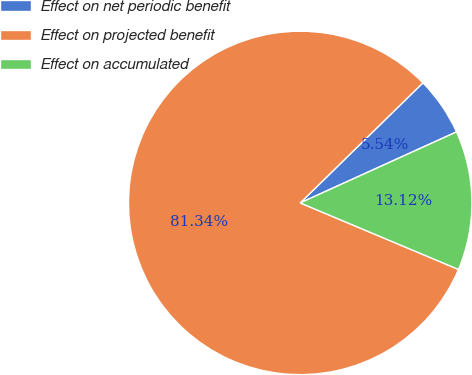Convert chart. <chart><loc_0><loc_0><loc_500><loc_500><pie_chart><fcel>Effect on net periodic benefit<fcel>Effect on projected benefit<fcel>Effect on accumulated<nl><fcel>5.54%<fcel>81.34%<fcel>13.12%<nl></chart> 